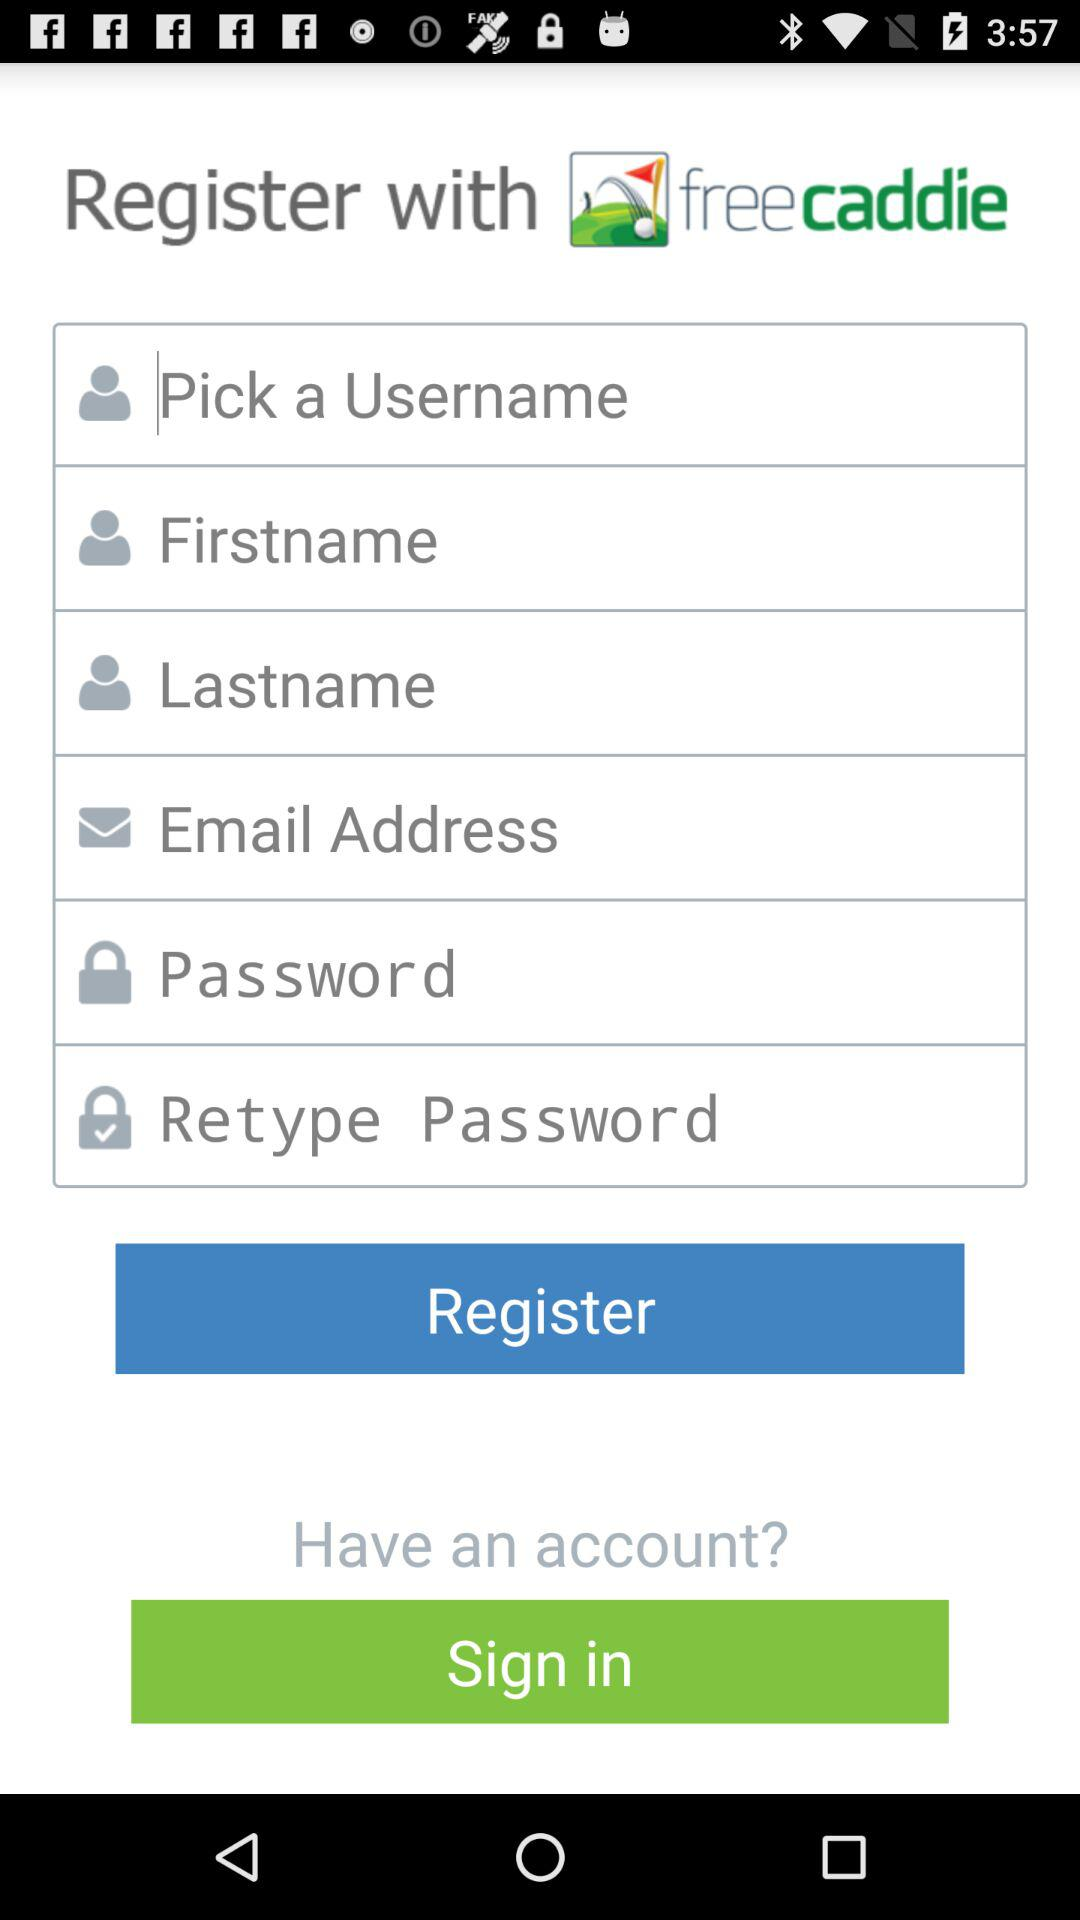What is the name of the application? The name of the application is "freecaddie". 